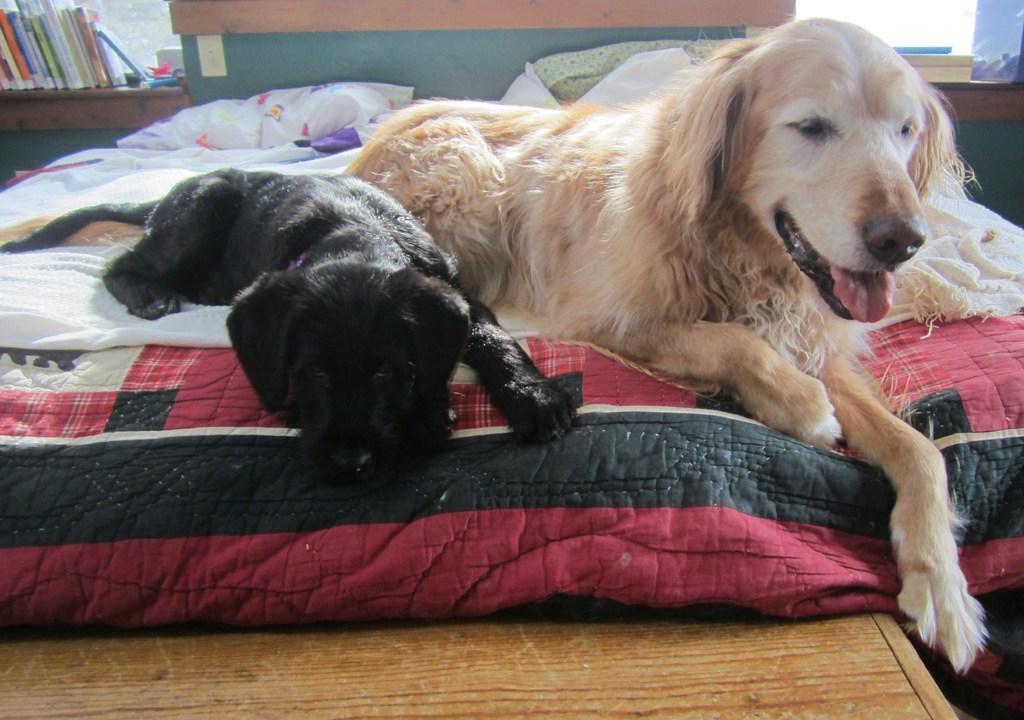How would you summarize this image in a sentence or two? This image is taken indoors. At the bottom of the image there is a wooden table. In the background there is a girl and there are a few books on the shelf and there are a few objects. There is a window. In the middle of the image two dogs are lying on the bed and there is a bed with bed sheet and pillows. 